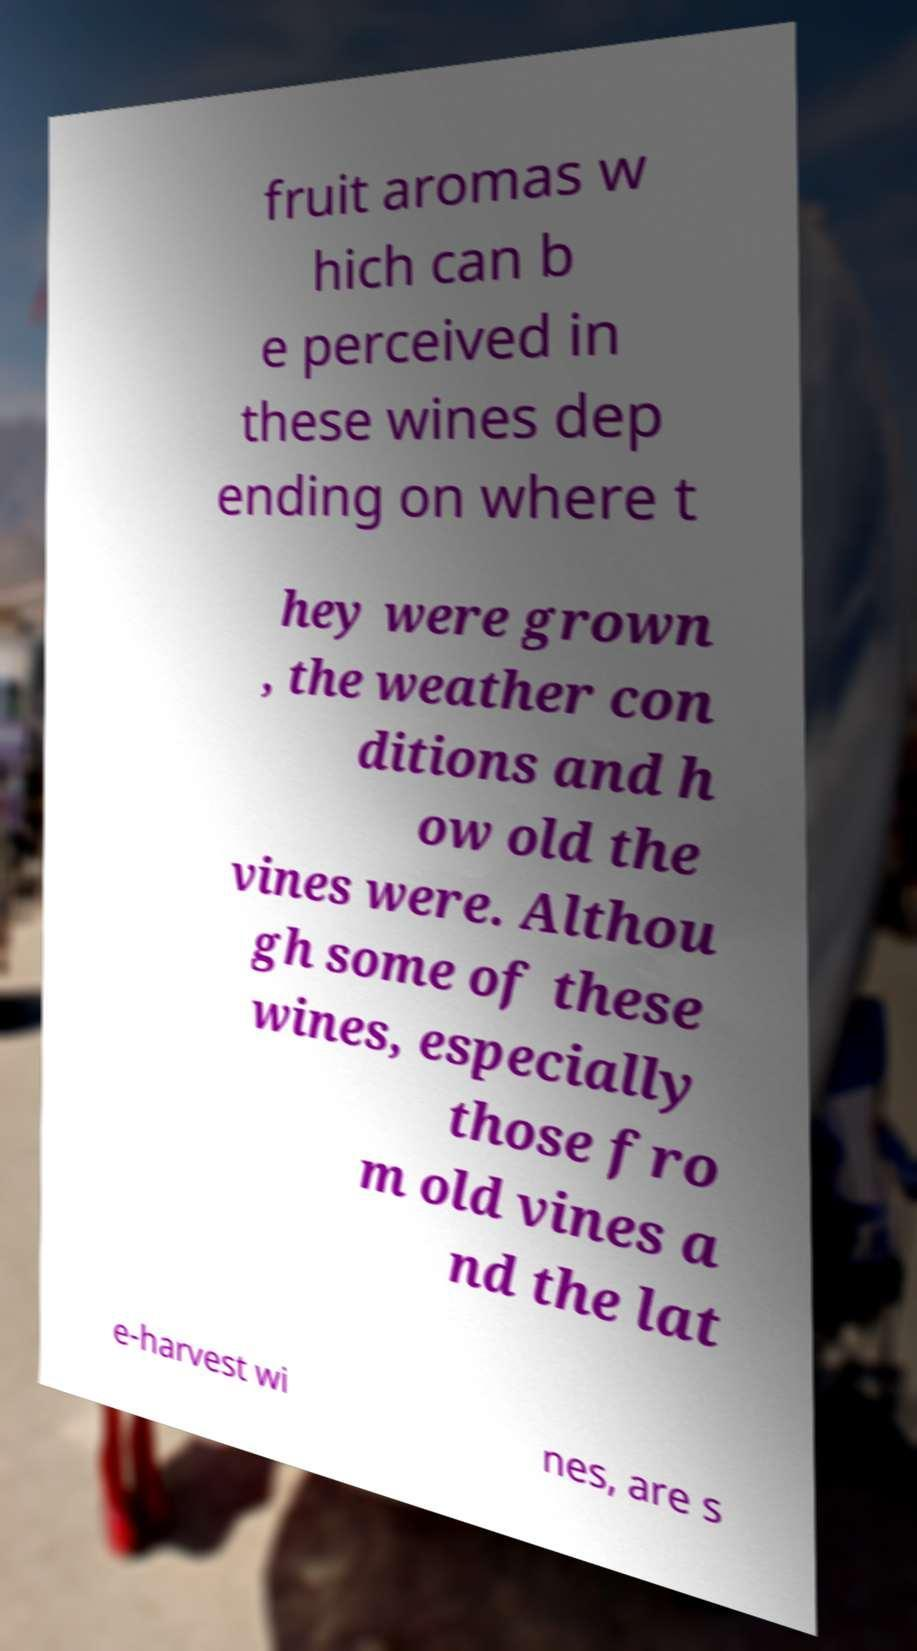Please identify and transcribe the text found in this image. fruit aromas w hich can b e perceived in these wines dep ending on where t hey were grown , the weather con ditions and h ow old the vines were. Althou gh some of these wines, especially those fro m old vines a nd the lat e-harvest wi nes, are s 